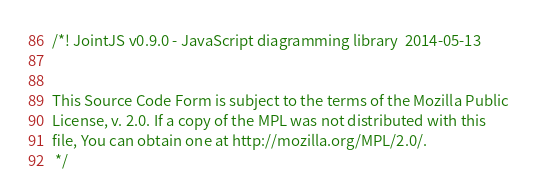Convert code to text. <code><loc_0><loc_0><loc_500><loc_500><_JavaScript_>/*! JointJS v0.9.0 - JavaScript diagramming library  2014-05-13 


This Source Code Form is subject to the terms of the Mozilla Public
License, v. 2.0. If a copy of the MPL was not distributed with this
file, You can obtain one at http://mozilla.org/MPL/2.0/.
 */</code> 